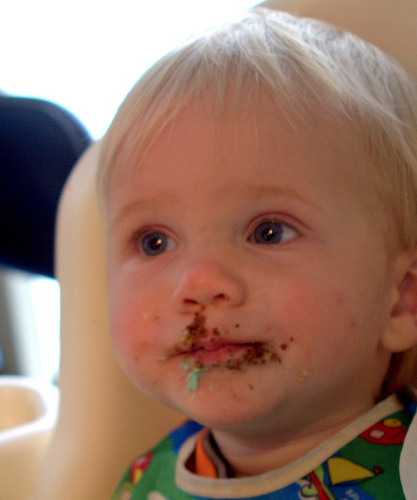<image>
Can you confirm if the cake crumbs is on the baby face? Yes. Looking at the image, I can see the cake crumbs is positioned on top of the baby face, with the baby face providing support. Is the cake to the left of the child? No. The cake is not to the left of the child. From this viewpoint, they have a different horizontal relationship. Is there a baby to the left of the food? No. The baby is not to the left of the food. From this viewpoint, they have a different horizontal relationship. 